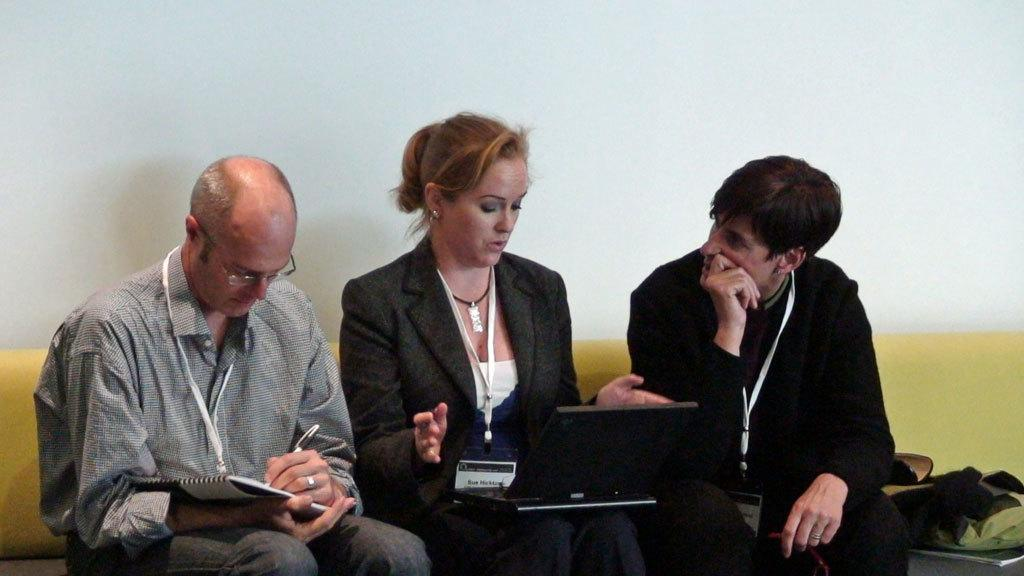How many people are in the image? There are three people in the image. Can you describe the gender of the people? Two of them are men, and one is a woman. What is the woman holding in the image? The woman is holding a laptop. Where are the people sitting in the image? The people are sitting on a sofa. What color is the wall in the background? The wall in the background is white. What type of lace can be seen on the gate in the image? There is no gate or lace present in the image. What is the purpose of the journey depicted in the image? There is no journey depicted in the image; it features three people sitting on a sofa. 